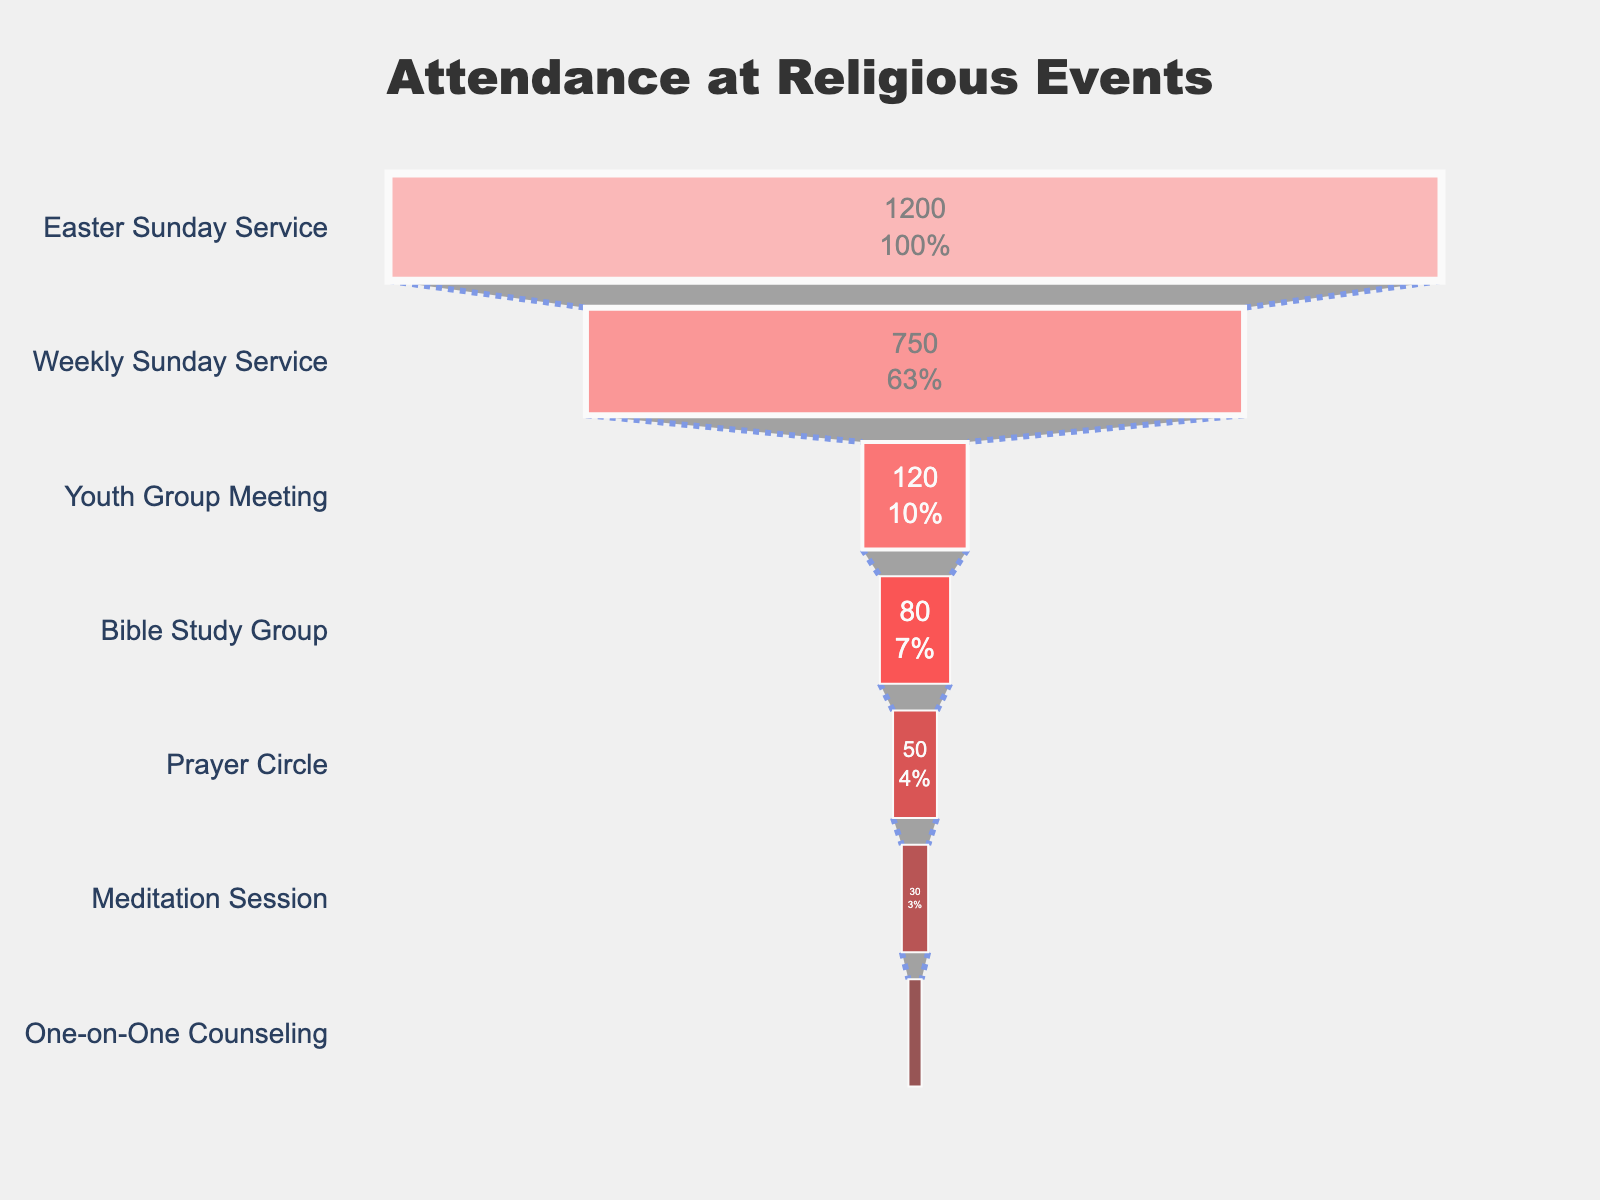How many events are displayed in the chart? Count the number of different events listed in the funnel chart.
Answer: 7 Which event has the highest attendance? Look at the top of the funnel chart which represents the event with the largest attendance.
Answer: Easter Sunday Service What's the percent decrease in attendance from the Weekly Sunday Service to the Youth Group Meeting? First, note the attendance for Weekly Sunday Service is 750 and for Youth Group Meeting is 120. Calculate the percentage decrease using: ((750 - 120) / 750) * 100.
Answer: 84% What is the total attendance for the bottom three events in the chart? Add the attendance numbers for Prayer Circle (50), Meditation Session (30), and One-on-One Counseling (15). The sum is 50 + 30 + 15.
Answer: 95 How does the attendance of Bible Study Group compare to Prayer Circle? Look at the attendance figures for both events: Bible Study Group has 80 and Prayer Circle has 50. Check which is larger.
Answer: Bible Study Group is larger Which event has the smallest attendance and how many attendees does it have? Look at the bottom of the funnel chart which signifies the event with the lowest attendance.
Answer: One-on-One Counseling, 15 attendees What's the cumulative attendance of all events combined? Sum the attendance numbers for all the events: 1200 + 750 + 120 + 80 + 50 + 30 + 15.
Answer: 2245 What percentage of the total attendance does Easter Sunday Service represent? Calculate the percentage using the formula: (attendance of Easter Sunday Service / total attendance) * 100 = (1200 / 2245) * 100.
Answer: 53.5% Is the drop in attendance between Easter Sunday Service and Weekly Sunday Service greater than the drop between Weekly Sunday Service and Youth Group Meeting? Compare the numerical drop between 1200 to 750 (450) and 750 to 120 (630). The drop is greater between Weekly Sunday Service and Youth Group Meeting.
Answer: Yes What is the median attendance value for the events listed? Arrange attendance values in ascending order: 15, 30, 50, 80, 120, 750, 1200. The middle value (4th value) is 80.
Answer: 80 